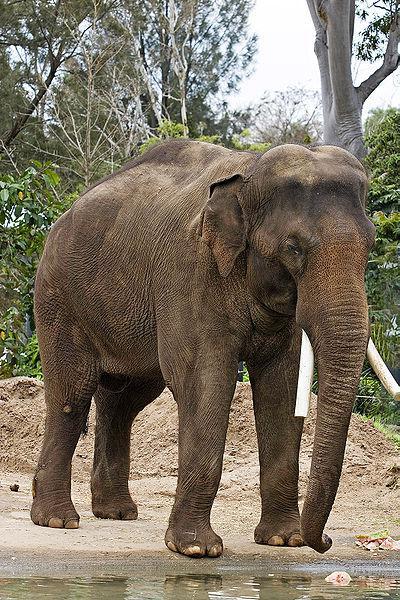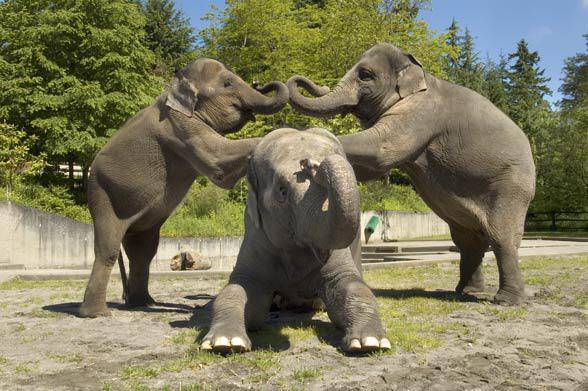The first image is the image on the left, the second image is the image on the right. Considering the images on both sides, is "Exactly two elephants are shown, one with its trunk hanging down, and one with its trunk curled up to its head, but both of them with tusks." valid? Answer yes or no. No. The first image is the image on the left, the second image is the image on the right. Given the left and right images, does the statement "One image features an elephant with tusks and a lowered trunk, and the other shows an elephant with tusks and a raised curled trunk." hold true? Answer yes or no. No. 